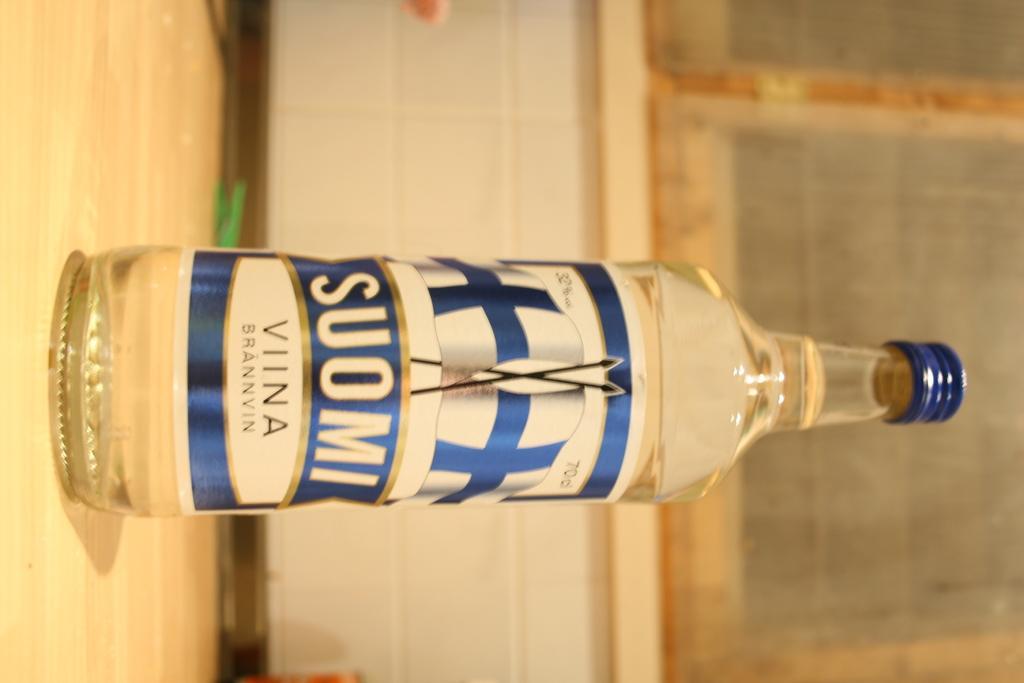Could you give a brief overview of what you see in this image? This picture is mainly highlighted with a bottle on the table. These are windows with mesh. 